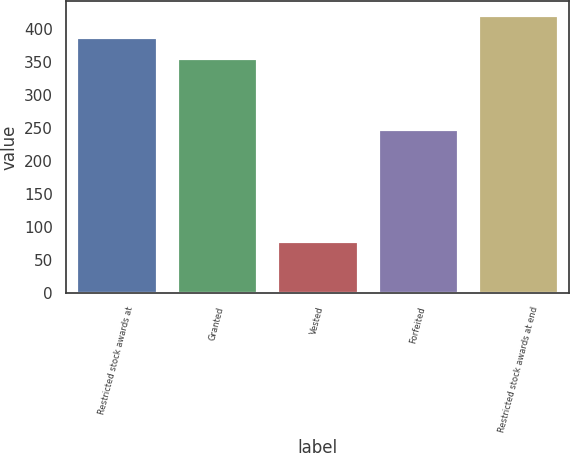<chart> <loc_0><loc_0><loc_500><loc_500><bar_chart><fcel>Restricted stock awards at<fcel>Granted<fcel>Vested<fcel>Forfeited<fcel>Restricted stock awards at end<nl><fcel>388.8<fcel>356<fcel>79<fcel>249<fcel>421.6<nl></chart> 